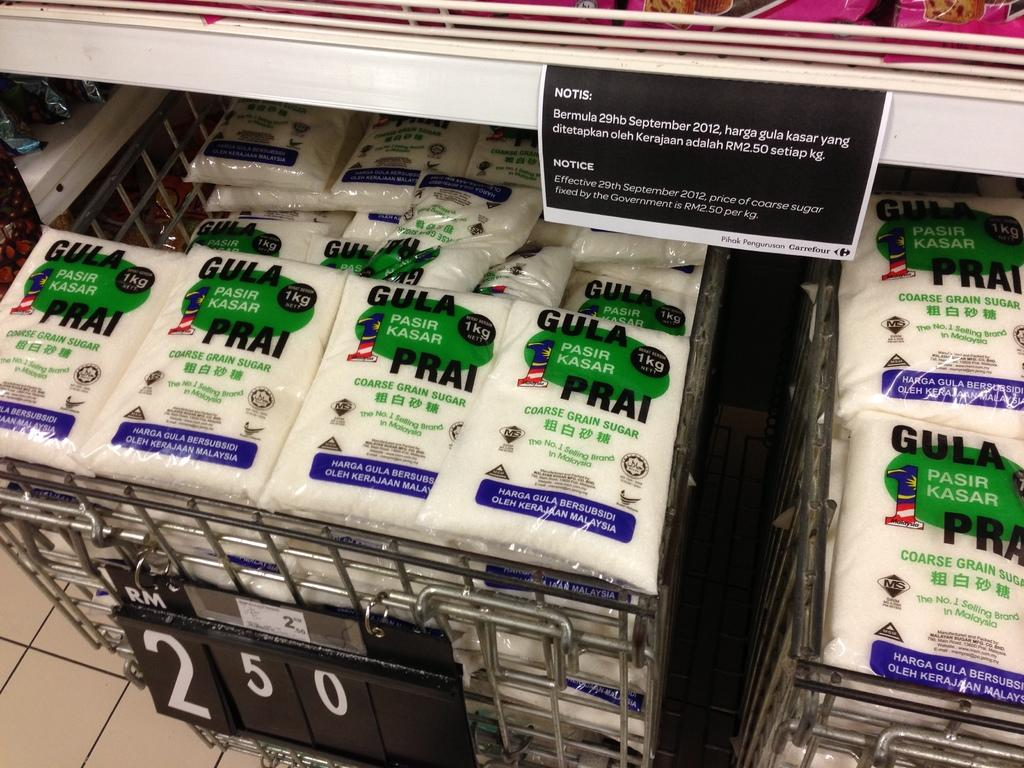Provide a one-sentence caption for the provided image. coarse grain sugar from Pasir Kasar in bins marked 2.50. 